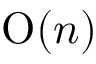Convert formula to latex. <formula><loc_0><loc_0><loc_500><loc_500>O ( n )</formula> 